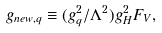Convert formula to latex. <formula><loc_0><loc_0><loc_500><loc_500>g _ { n e w , q } \equiv ( g _ { q } ^ { 2 } / \Lambda ^ { 2 } ) g _ { H } ^ { 2 } F _ { V } ,</formula> 